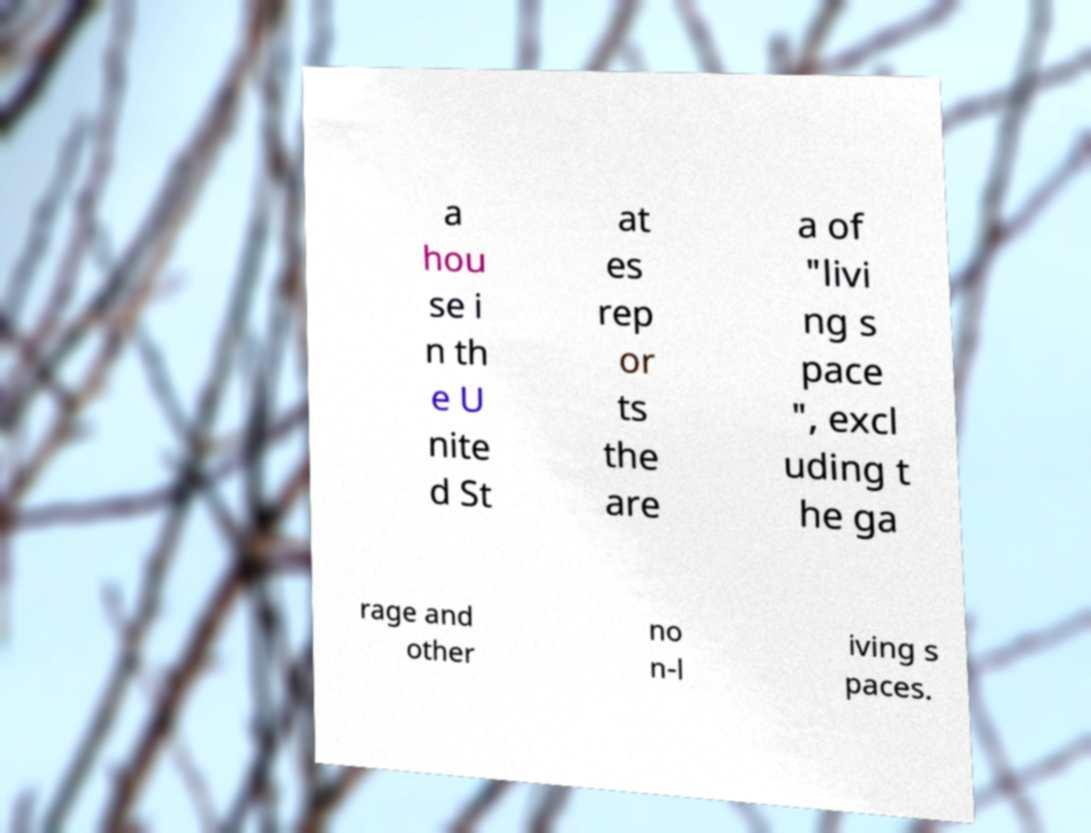I need the written content from this picture converted into text. Can you do that? a hou se i n th e U nite d St at es rep or ts the are a of "livi ng s pace ", excl uding t he ga rage and other no n-l iving s paces. 